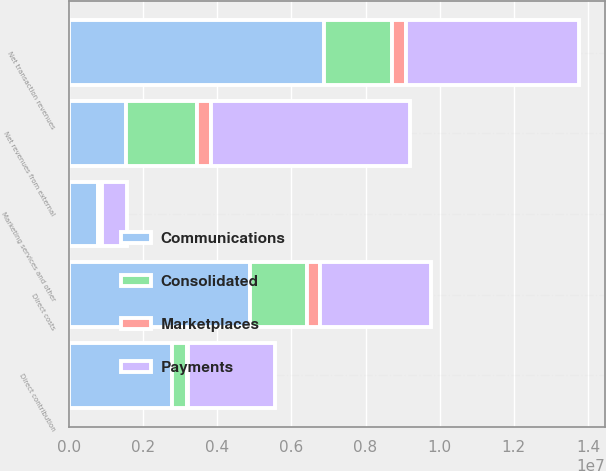Convert chart. <chart><loc_0><loc_0><loc_500><loc_500><stacked_bar_chart><ecel><fcel>Net transaction revenues<fcel>Marketing services and other<fcel>Net revenues from external<fcel>Direct costs<fcel>Direct contribution<nl><fcel>Payments<fcel>4.68084e+06<fcel>683056<fcel>5.36389e+06<fcel>3.0179e+06<fcel>2.346e+06<nl><fcel>Consolidated<fcel>1.83854e+06<fcel>88077<fcel>1.92662e+06<fcel>1.53463e+06<fcel>391989<nl><fcel>Marketplaces<fcel>364564<fcel>17258<fcel>381822<fcel>337338<fcel>44484<nl><fcel>Communications<fcel>6.88394e+06<fcel>788391<fcel>1.53463e+06<fcel>4.88986e+06<fcel>2.78247e+06<nl></chart> 